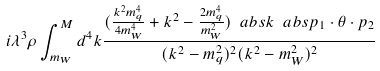<formula> <loc_0><loc_0><loc_500><loc_500>i \lambda ^ { 3 } \rho \int ^ { M } _ { m _ { W } } { d ^ { 4 } k \frac { ( \frac { k ^ { 2 } m _ { q } ^ { 4 } } { 4 m _ { W } ^ { 4 } } + k ^ { 2 } - \frac { 2 m _ { q } ^ { 4 } } { m _ { W } ^ { 2 } } ) \ a b s { k } \ a b s { p _ { 1 } \cdot \theta \cdot p _ { 2 } } } { ( k ^ { 2 } - m _ { q } ^ { 2 } ) ^ { 2 } ( k ^ { 2 } - m _ { W } ^ { 2 } ) ^ { 2 } } }</formula> 